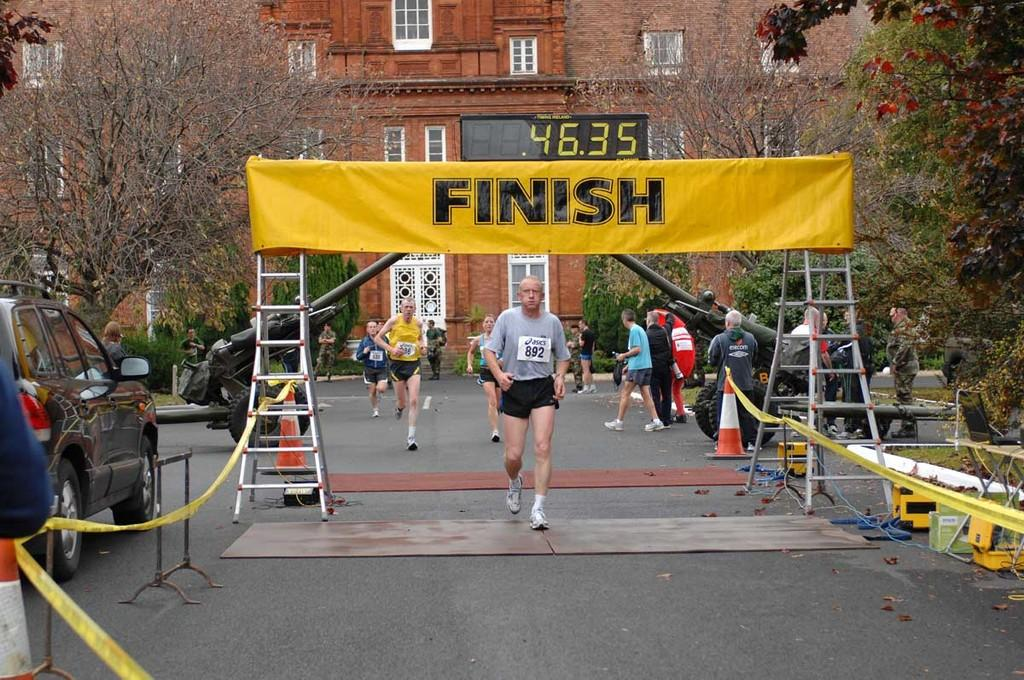What are the people in the image doing? The people in the image are running on the road. What can be seen on the left side of the image? There is a car on the left side of the image. What is visible in the background of the image? There are trees and a building visible in the background of the image. How many apples are being held by the sister in the image? There is no sister or apples present in the image. What type of tin is visible in the image? There is no tin present in the image. 